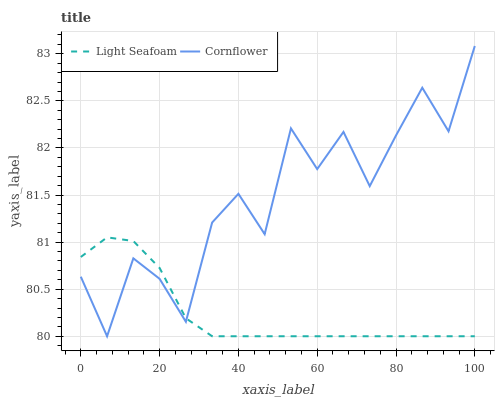Does Light Seafoam have the minimum area under the curve?
Answer yes or no. Yes. Does Cornflower have the maximum area under the curve?
Answer yes or no. Yes. Does Light Seafoam have the maximum area under the curve?
Answer yes or no. No. Is Light Seafoam the smoothest?
Answer yes or no. Yes. Is Cornflower the roughest?
Answer yes or no. Yes. Is Light Seafoam the roughest?
Answer yes or no. No. Does Cornflower have the highest value?
Answer yes or no. Yes. Does Light Seafoam have the highest value?
Answer yes or no. No. 